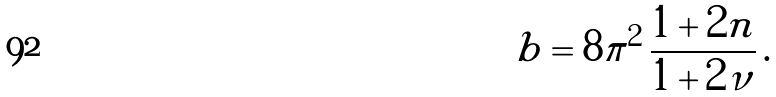Convert formula to latex. <formula><loc_0><loc_0><loc_500><loc_500>b = 8 \pi ^ { 2 } \, \frac { 1 + 2 n } { 1 + 2 \nu } \, .</formula> 